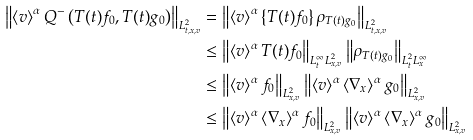<formula> <loc_0><loc_0><loc_500><loc_500>\left \| \left < v \right > ^ { \alpha } Q ^ { - } \left ( T ( t ) f _ { 0 } , T ( t ) g _ { 0 } \right ) \right \| _ { L ^ { 2 } _ { t , x , v } } & = \left \| \left < v \right > ^ { \alpha } \left \{ T ( t ) f _ { 0 } \right \} \rho _ { T ( t ) g _ { 0 } } \right \| _ { L ^ { 2 } _ { t , x , v } } \\ & \leq \left \| \left < v \right > ^ { \alpha } T ( t ) f _ { 0 } \right \| _ { L ^ { \infty } _ { t } L ^ { 2 } _ { x , v } } \left \| \rho _ { T ( t ) g _ { 0 } } \right \| _ { L ^ { 2 } _ { t } L ^ { \infty } _ { x } } \\ & \leq \left \| \left < v \right > ^ { \alpha } f _ { 0 } \right \| _ { L ^ { 2 } _ { x , v } } \left \| \left < v \right > ^ { \alpha } \left < \nabla _ { x } \right > ^ { \alpha } g _ { 0 } \right \| _ { L ^ { 2 } _ { x , v } } \\ & \leq \left \| \left < v \right > ^ { \alpha } \left < \nabla _ { x } \right > ^ { \alpha } f _ { 0 } \right \| _ { L ^ { 2 } _ { x , v } } \left \| \left < v \right > ^ { \alpha } \left < \nabla _ { x } \right > ^ { \alpha } g _ { 0 } \right \| _ { L ^ { 2 } _ { x , v } }</formula> 